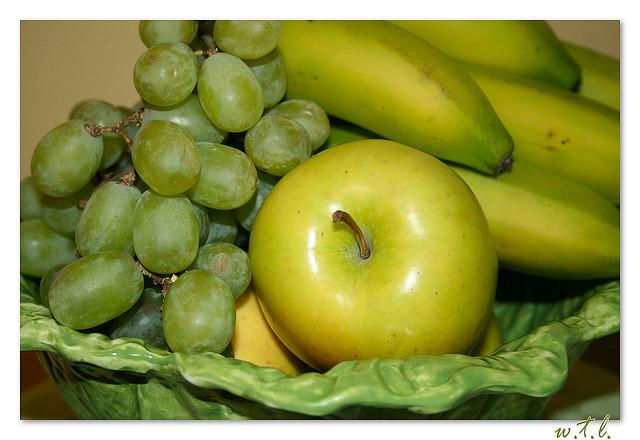What food items are in the picture?
Quick response, please. Grapes, apples, bananas. What color are the fruits and veggies?
Keep it brief. Green. Are the strawberries in the bowl ripe?
Short answer required. No. 